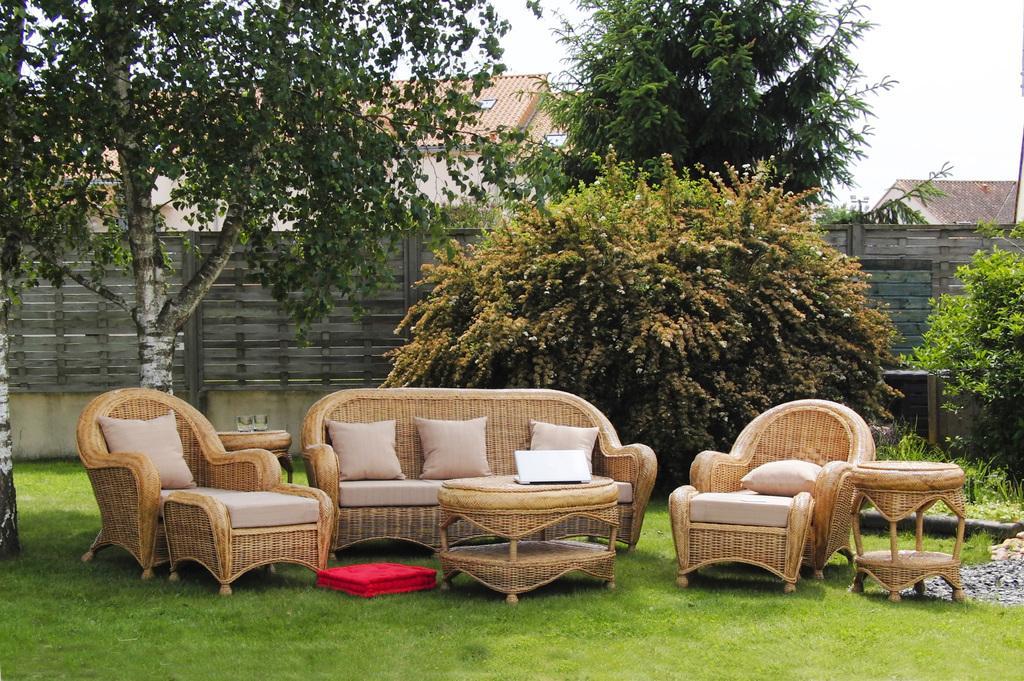Can you describe this image briefly? In this image, There is grass in green color, There are some chairs and sofa in yellow color and there are some tables in yellow color and in the background there are some plants and trees which are in green color, There is a wooden wall in gray color and there is a sky in white color. 